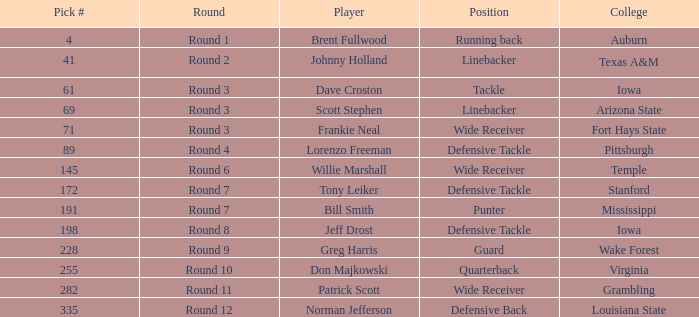What is the aggregate of pick# for don majkowski? 255.0. I'm looking to parse the entire table for insights. Could you assist me with that? {'header': ['Pick #', 'Round', 'Player', 'Position', 'College'], 'rows': [['4', 'Round 1', 'Brent Fullwood', 'Running back', 'Auburn'], ['41', 'Round 2', 'Johnny Holland', 'Linebacker', 'Texas A&M'], ['61', 'Round 3', 'Dave Croston', 'Tackle', 'Iowa'], ['69', 'Round 3', 'Scott Stephen', 'Linebacker', 'Arizona State'], ['71', 'Round 3', 'Frankie Neal', 'Wide Receiver', 'Fort Hays State'], ['89', 'Round 4', 'Lorenzo Freeman', 'Defensive Tackle', 'Pittsburgh'], ['145', 'Round 6', 'Willie Marshall', 'Wide Receiver', 'Temple'], ['172', 'Round 7', 'Tony Leiker', 'Defensive Tackle', 'Stanford'], ['191', 'Round 7', 'Bill Smith', 'Punter', 'Mississippi'], ['198', 'Round 8', 'Jeff Drost', 'Defensive Tackle', 'Iowa'], ['228', 'Round 9', 'Greg Harris', 'Guard', 'Wake Forest'], ['255', 'Round 10', 'Don Majkowski', 'Quarterback', 'Virginia'], ['282', 'Round 11', 'Patrick Scott', 'Wide Receiver', 'Grambling'], ['335', 'Round 12', 'Norman Jefferson', 'Defensive Back', 'Louisiana State']]} 